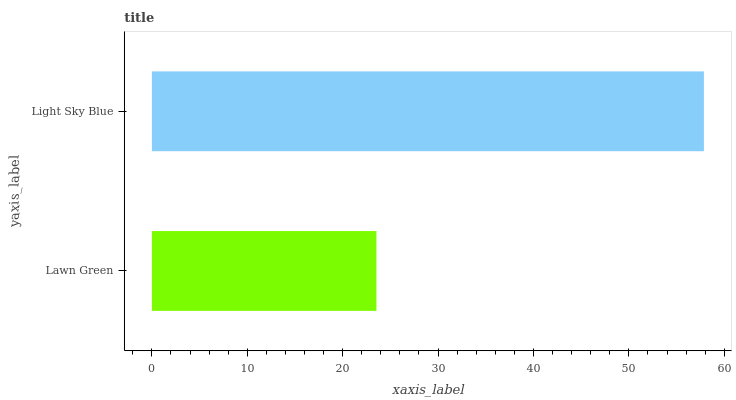Is Lawn Green the minimum?
Answer yes or no. Yes. Is Light Sky Blue the maximum?
Answer yes or no. Yes. Is Light Sky Blue the minimum?
Answer yes or no. No. Is Light Sky Blue greater than Lawn Green?
Answer yes or no. Yes. Is Lawn Green less than Light Sky Blue?
Answer yes or no. Yes. Is Lawn Green greater than Light Sky Blue?
Answer yes or no. No. Is Light Sky Blue less than Lawn Green?
Answer yes or no. No. Is Light Sky Blue the high median?
Answer yes or no. Yes. Is Lawn Green the low median?
Answer yes or no. Yes. Is Lawn Green the high median?
Answer yes or no. No. Is Light Sky Blue the low median?
Answer yes or no. No. 